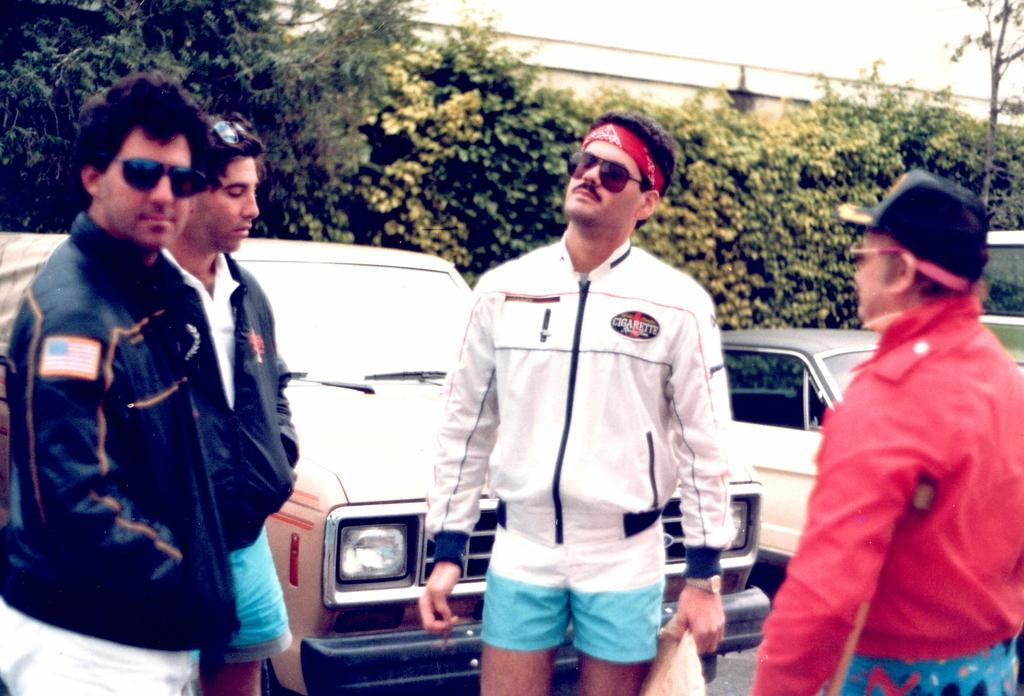What is the main subject of the image? The main subject of the image is a group of people. Can you describe any specific features of the people in the group? Some people in the group are wearing spectacles. What can be seen in the background of the image? There are cars and trees visible in the background of the image. What type of account is being discussed by the people in the image? There is no indication in the image that the people are discussing any type of account. 